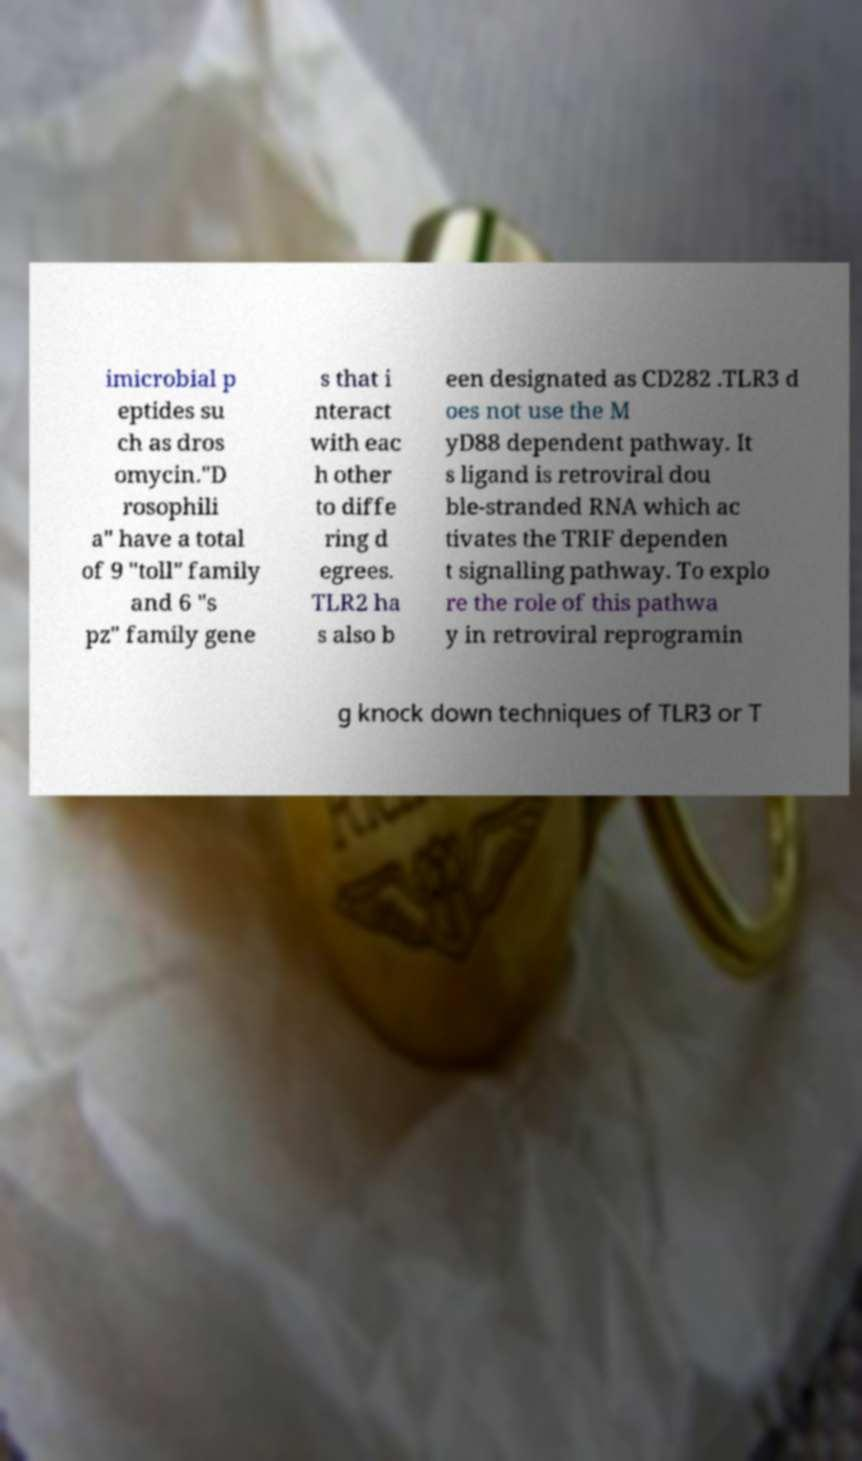What messages or text are displayed in this image? I need them in a readable, typed format. imicrobial p eptides su ch as dros omycin."D rosophili a" have a total of 9 "toll" family and 6 "s pz" family gene s that i nteract with eac h other to diffe ring d egrees. TLR2 ha s also b een designated as CD282 .TLR3 d oes not use the M yD88 dependent pathway. It s ligand is retroviral dou ble-stranded RNA which ac tivates the TRIF dependen t signalling pathway. To explo re the role of this pathwa y in retroviral reprogramin g knock down techniques of TLR3 or T 